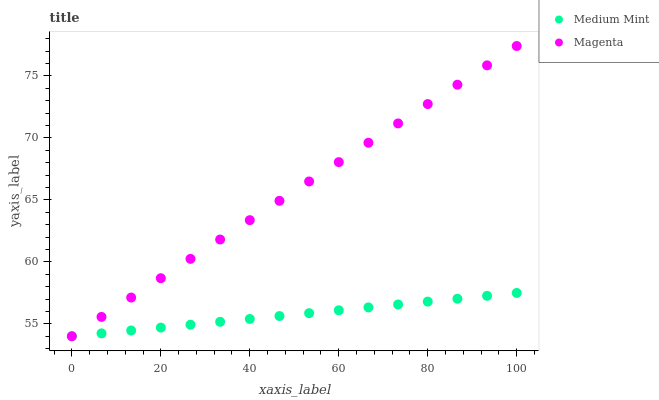Does Medium Mint have the minimum area under the curve?
Answer yes or no. Yes. Does Magenta have the maximum area under the curve?
Answer yes or no. Yes. Does Magenta have the minimum area under the curve?
Answer yes or no. No. Is Medium Mint the smoothest?
Answer yes or no. Yes. Is Magenta the roughest?
Answer yes or no. Yes. Is Magenta the smoothest?
Answer yes or no. No. Does Medium Mint have the lowest value?
Answer yes or no. Yes. Does Magenta have the highest value?
Answer yes or no. Yes. Does Magenta intersect Medium Mint?
Answer yes or no. Yes. Is Magenta less than Medium Mint?
Answer yes or no. No. Is Magenta greater than Medium Mint?
Answer yes or no. No. 